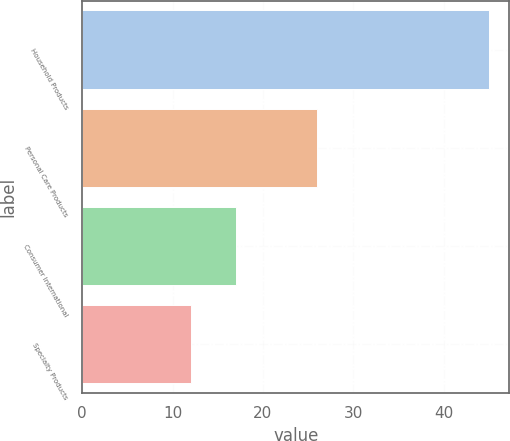Convert chart. <chart><loc_0><loc_0><loc_500><loc_500><bar_chart><fcel>Household Products<fcel>Personal Care Products<fcel>Consumer International<fcel>Specialty Products<nl><fcel>45<fcel>26<fcel>17<fcel>12<nl></chart> 